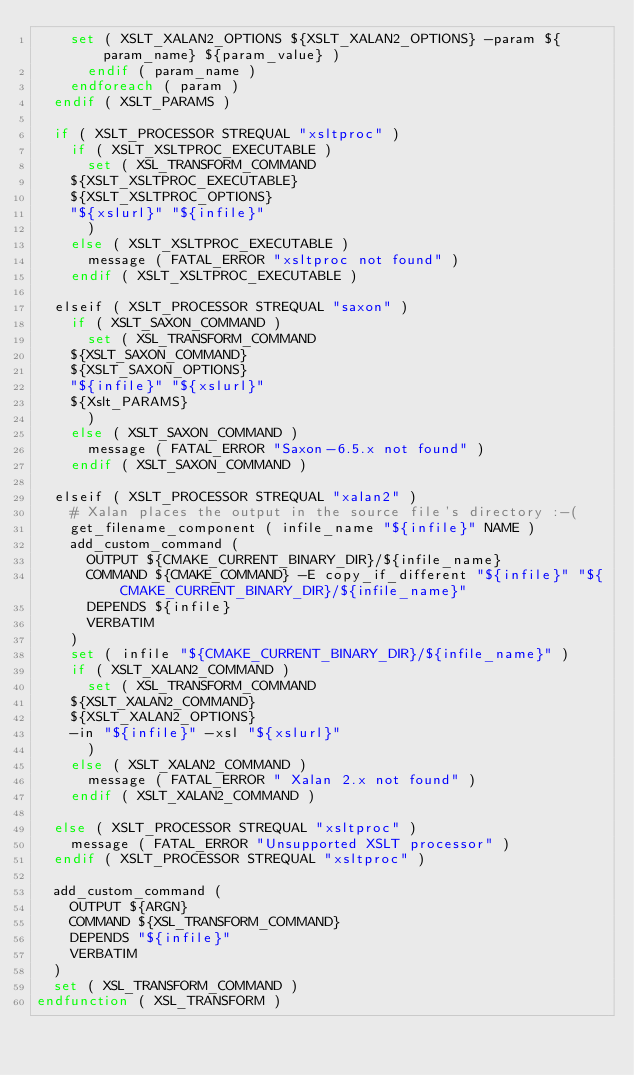Convert code to text. <code><loc_0><loc_0><loc_500><loc_500><_CMake_>	set ( XSLT_XALAN2_OPTIONS ${XSLT_XALAN2_OPTIONS} -param ${param_name} ${param_value} )
      endif ( param_name )
    endforeach ( param )
  endif ( XSLT_PARAMS )

  if ( XSLT_PROCESSOR STREQUAL "xsltproc" )
    if ( XSLT_XSLTPROC_EXECUTABLE )
      set ( XSL_TRANSFORM_COMMAND
	${XSLT_XSLTPROC_EXECUTABLE}
	${XSLT_XSLTPROC_OPTIONS}
	"${xslurl}" "${infile}"
      )
    else ( XSLT_XSLTPROC_EXECUTABLE )
      message ( FATAL_ERROR "xsltproc not found" )
    endif ( XSLT_XSLTPROC_EXECUTABLE )

  elseif ( XSLT_PROCESSOR STREQUAL "saxon" )
    if ( XSLT_SAXON_COMMAND )
      set ( XSL_TRANSFORM_COMMAND
	${XSLT_SAXON_COMMAND}
	${XSLT_SAXON_OPTIONS}
	"${infile}" "${xslurl}"
	${Xslt_PARAMS}
      )
    else ( XSLT_SAXON_COMMAND )
      message ( FATAL_ERROR "Saxon-6.5.x not found" )
    endif ( XSLT_SAXON_COMMAND )

  elseif ( XSLT_PROCESSOR STREQUAL "xalan2" )
    # Xalan places the output in the source file's directory :-(
    get_filename_component ( infile_name "${infile}" NAME )
    add_custom_command (
      OUTPUT ${CMAKE_CURRENT_BINARY_DIR}/${infile_name}
      COMMAND ${CMAKE_COMMAND} -E copy_if_different "${infile}" "${CMAKE_CURRENT_BINARY_DIR}/${infile_name}"
      DEPENDS ${infile}
      VERBATIM
    )
    set ( infile "${CMAKE_CURRENT_BINARY_DIR}/${infile_name}" )
    if ( XSLT_XALAN2_COMMAND )
      set ( XSL_TRANSFORM_COMMAND
	${XSLT_XALAN2_COMMAND}
	${XSLT_XALAN2_OPTIONS}
	-in "${infile}" -xsl "${xslurl}"
      )
    else ( XSLT_XALAN2_COMMAND )
      message ( FATAL_ERROR " Xalan 2.x not found" )
    endif ( XSLT_XALAN2_COMMAND )

  else ( XSLT_PROCESSOR STREQUAL "xsltproc" )
    message ( FATAL_ERROR "Unsupported XSLT processor" )
  endif ( XSLT_PROCESSOR STREQUAL "xsltproc" )

  add_custom_command (
    OUTPUT ${ARGN}
    COMMAND ${XSL_TRANSFORM_COMMAND}
    DEPENDS "${infile}"
    VERBATIM
  )
  set ( XSL_TRANSFORM_COMMAND )
endfunction ( XSL_TRANSFORM )
</code> 